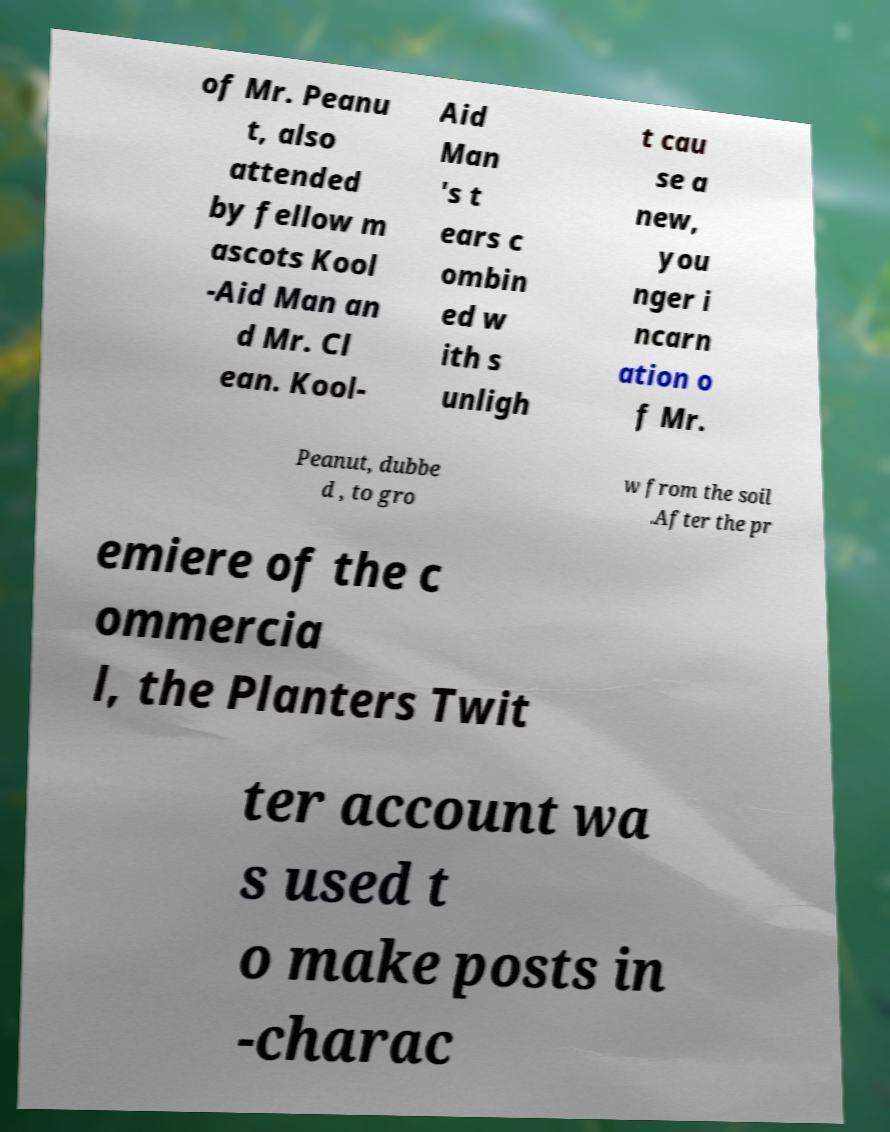Can you read and provide the text displayed in the image?This photo seems to have some interesting text. Can you extract and type it out for me? of Mr. Peanu t, also attended by fellow m ascots Kool -Aid Man an d Mr. Cl ean. Kool- Aid Man 's t ears c ombin ed w ith s unligh t cau se a new, you nger i ncarn ation o f Mr. Peanut, dubbe d , to gro w from the soil .After the pr emiere of the c ommercia l, the Planters Twit ter account wa s used t o make posts in -charac 